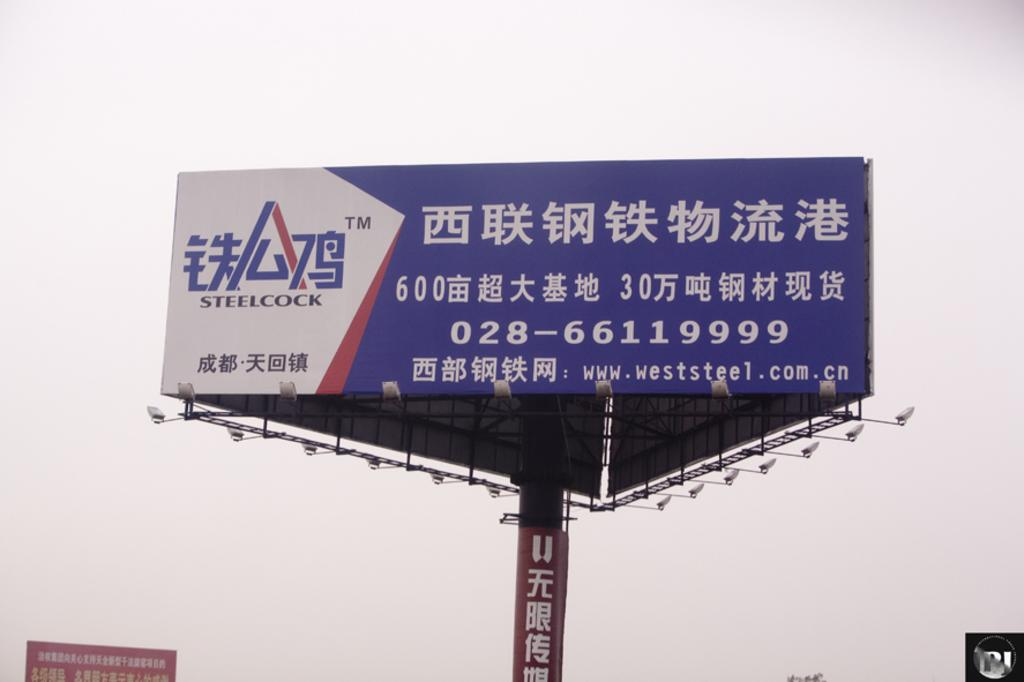<image>
Describe the image concisely. A red, white, and blue billboard that is written in Chinese has the email www.weststeel.com.cn. 